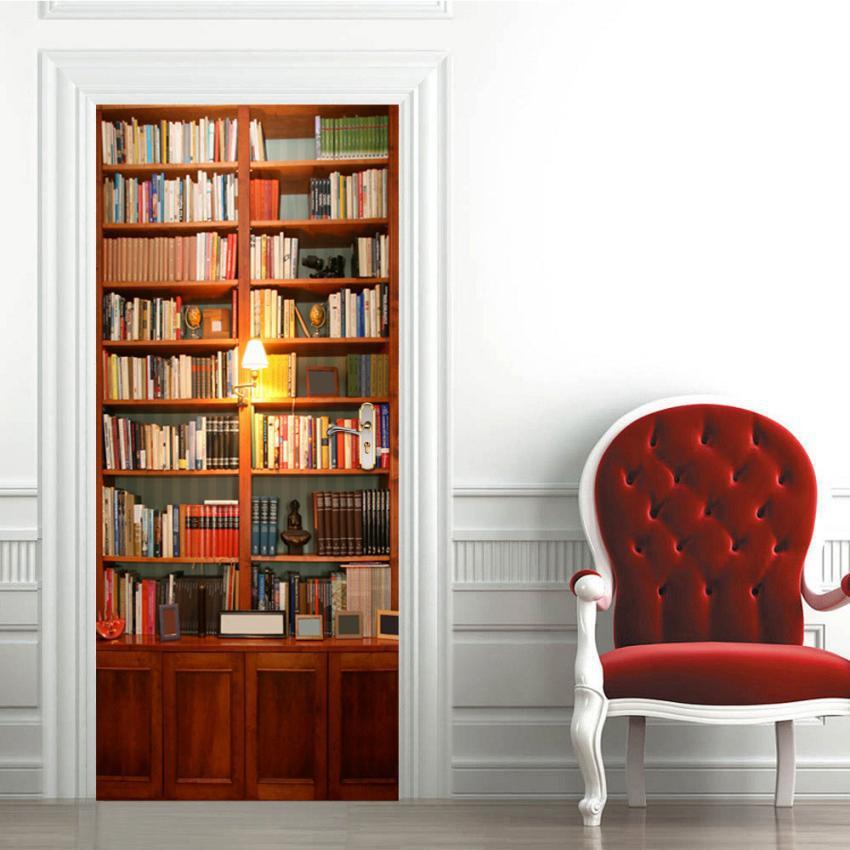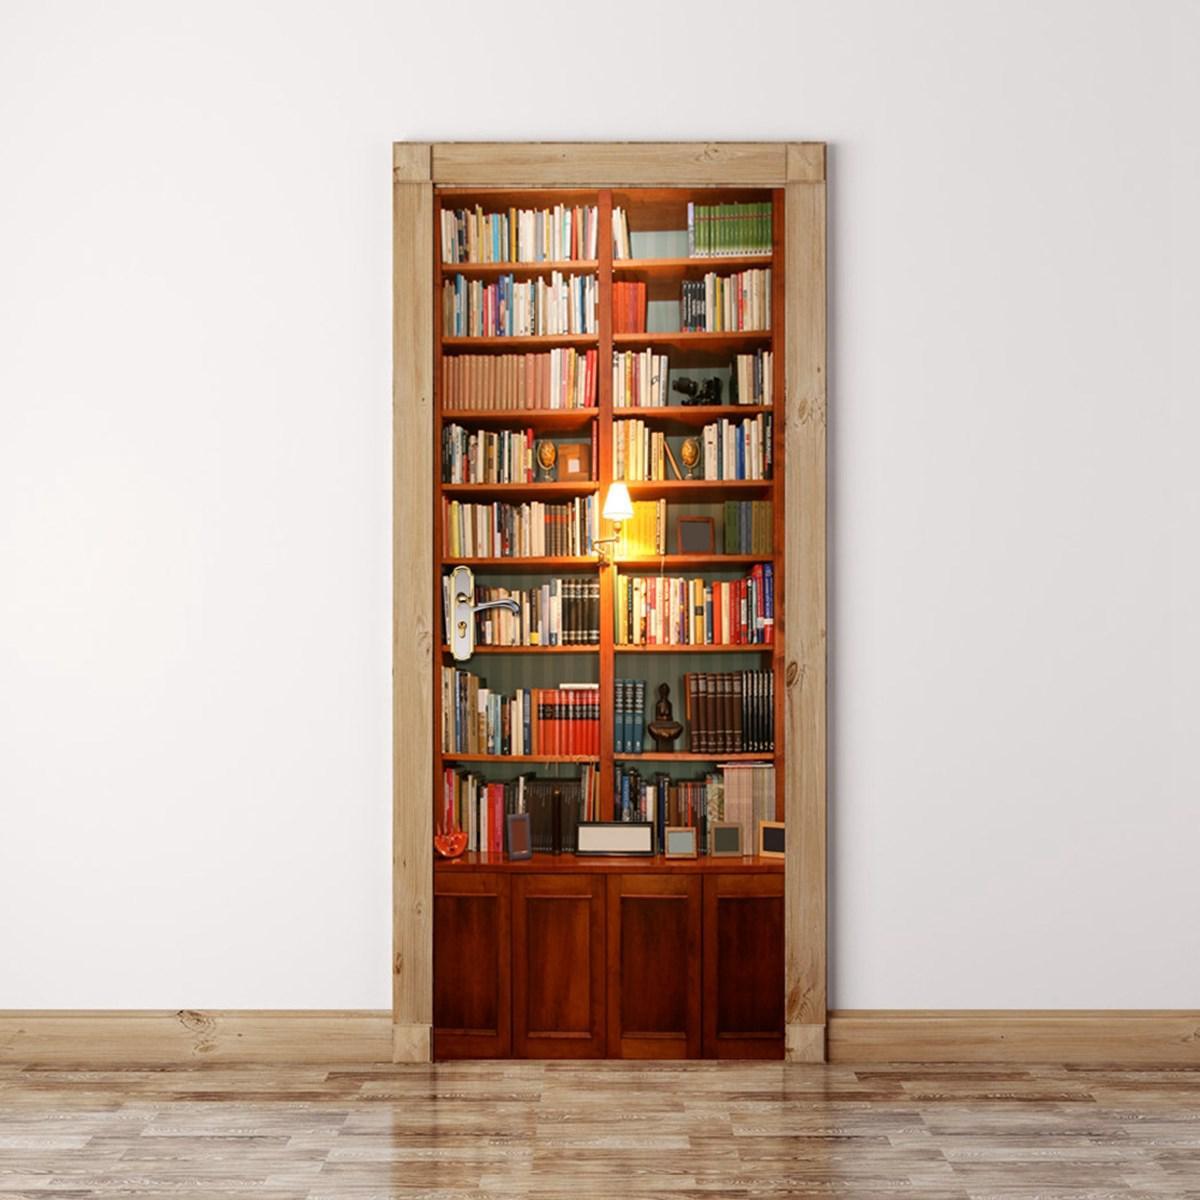The first image is the image on the left, the second image is the image on the right. Given the left and right images, does the statement "An object is next to one of the bookcases." hold true? Answer yes or no. Yes. The first image is the image on the left, the second image is the image on the right. Considering the images on both sides, is "At least one image features a bookcase with reddish-brown panels at the bottom and eight vertical shelves." valid? Answer yes or no. Yes. 